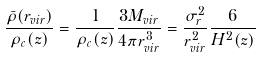Convert formula to latex. <formula><loc_0><loc_0><loc_500><loc_500>\frac { \bar { \rho } ( r _ { v i r } ) } { \rho _ { c } ( z ) } = \frac { 1 } { \rho _ { c } ( z ) } \frac { 3 M _ { v i r } } { 4 \pi r _ { v i r } ^ { 3 } } = \frac { \sigma _ { r } ^ { 2 } } { r _ { v i r } ^ { 2 } } \frac { 6 } { H ^ { 2 } ( z ) }</formula> 